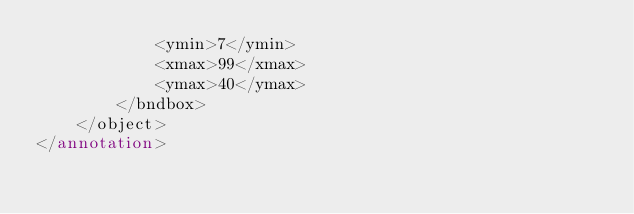<code> <loc_0><loc_0><loc_500><loc_500><_XML_>			<ymin>7</ymin>
			<xmax>99</xmax>
			<ymax>40</ymax>
		</bndbox>
	</object>
</annotation>
</code> 